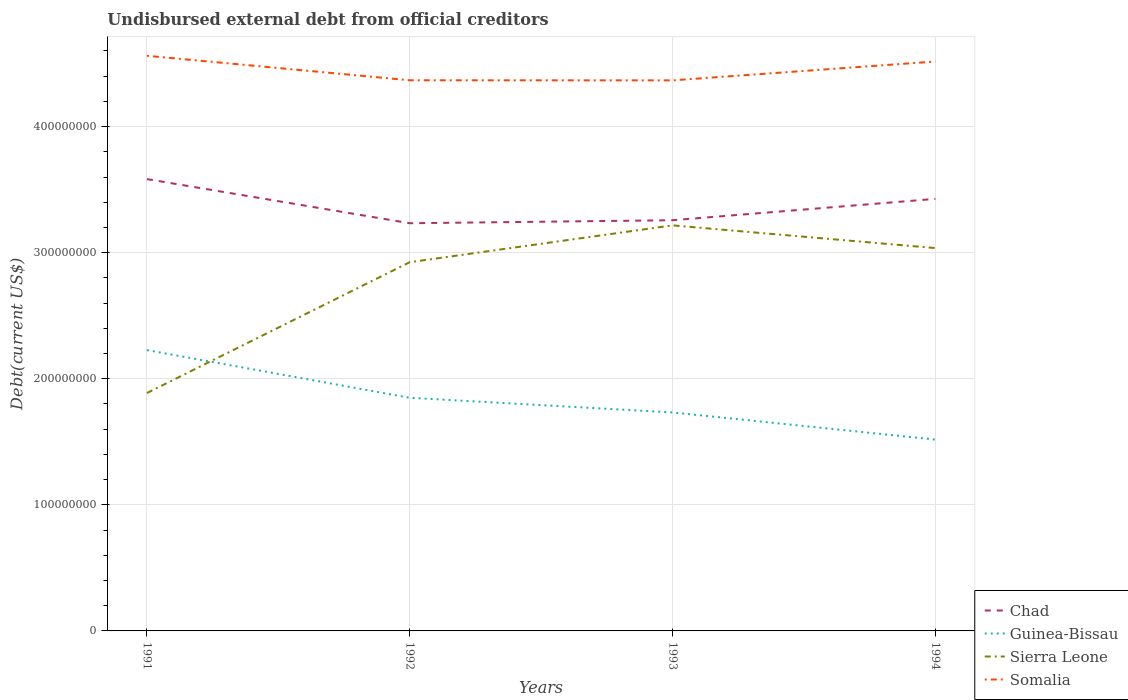How many different coloured lines are there?
Your answer should be very brief. 4. Across all years, what is the maximum total debt in Sierra Leone?
Give a very brief answer. 1.89e+08. In which year was the total debt in Chad maximum?
Your answer should be compact. 1992. What is the total total debt in Chad in the graph?
Ensure brevity in your answer.  3.26e+07. What is the difference between the highest and the second highest total debt in Chad?
Ensure brevity in your answer.  3.50e+07. What is the difference between the highest and the lowest total debt in Somalia?
Make the answer very short. 2. How many lines are there?
Offer a terse response. 4. How many years are there in the graph?
Offer a very short reply. 4. Are the values on the major ticks of Y-axis written in scientific E-notation?
Give a very brief answer. No. How many legend labels are there?
Make the answer very short. 4. What is the title of the graph?
Your answer should be very brief. Undisbursed external debt from official creditors. Does "Belarus" appear as one of the legend labels in the graph?
Your response must be concise. No. What is the label or title of the X-axis?
Give a very brief answer. Years. What is the label or title of the Y-axis?
Keep it short and to the point. Debt(current US$). What is the Debt(current US$) in Chad in 1991?
Ensure brevity in your answer.  3.58e+08. What is the Debt(current US$) in Guinea-Bissau in 1991?
Give a very brief answer. 2.23e+08. What is the Debt(current US$) in Sierra Leone in 1991?
Ensure brevity in your answer.  1.89e+08. What is the Debt(current US$) of Somalia in 1991?
Give a very brief answer. 4.56e+08. What is the Debt(current US$) in Chad in 1992?
Keep it short and to the point. 3.23e+08. What is the Debt(current US$) in Guinea-Bissau in 1992?
Your response must be concise. 1.85e+08. What is the Debt(current US$) in Sierra Leone in 1992?
Give a very brief answer. 2.92e+08. What is the Debt(current US$) in Somalia in 1992?
Your answer should be compact. 4.37e+08. What is the Debt(current US$) in Chad in 1993?
Your answer should be very brief. 3.26e+08. What is the Debt(current US$) in Guinea-Bissau in 1993?
Ensure brevity in your answer.  1.73e+08. What is the Debt(current US$) of Sierra Leone in 1993?
Give a very brief answer. 3.22e+08. What is the Debt(current US$) of Somalia in 1993?
Offer a terse response. 4.37e+08. What is the Debt(current US$) of Chad in 1994?
Keep it short and to the point. 3.43e+08. What is the Debt(current US$) in Guinea-Bissau in 1994?
Ensure brevity in your answer.  1.52e+08. What is the Debt(current US$) in Sierra Leone in 1994?
Offer a terse response. 3.04e+08. What is the Debt(current US$) of Somalia in 1994?
Offer a terse response. 4.52e+08. Across all years, what is the maximum Debt(current US$) in Chad?
Provide a succinct answer. 3.58e+08. Across all years, what is the maximum Debt(current US$) of Guinea-Bissau?
Give a very brief answer. 2.23e+08. Across all years, what is the maximum Debt(current US$) in Sierra Leone?
Make the answer very short. 3.22e+08. Across all years, what is the maximum Debt(current US$) in Somalia?
Keep it short and to the point. 4.56e+08. Across all years, what is the minimum Debt(current US$) of Chad?
Make the answer very short. 3.23e+08. Across all years, what is the minimum Debt(current US$) in Guinea-Bissau?
Offer a terse response. 1.52e+08. Across all years, what is the minimum Debt(current US$) in Sierra Leone?
Your response must be concise. 1.89e+08. Across all years, what is the minimum Debt(current US$) of Somalia?
Give a very brief answer. 4.37e+08. What is the total Debt(current US$) in Chad in the graph?
Ensure brevity in your answer.  1.35e+09. What is the total Debt(current US$) of Guinea-Bissau in the graph?
Offer a very short reply. 7.33e+08. What is the total Debt(current US$) of Sierra Leone in the graph?
Keep it short and to the point. 1.11e+09. What is the total Debt(current US$) in Somalia in the graph?
Offer a terse response. 1.78e+09. What is the difference between the Debt(current US$) in Chad in 1991 and that in 1992?
Provide a succinct answer. 3.50e+07. What is the difference between the Debt(current US$) of Guinea-Bissau in 1991 and that in 1992?
Keep it short and to the point. 3.78e+07. What is the difference between the Debt(current US$) of Sierra Leone in 1991 and that in 1992?
Your response must be concise. -1.04e+08. What is the difference between the Debt(current US$) of Somalia in 1991 and that in 1992?
Make the answer very short. 1.94e+07. What is the difference between the Debt(current US$) in Chad in 1991 and that in 1993?
Offer a terse response. 3.26e+07. What is the difference between the Debt(current US$) of Guinea-Bissau in 1991 and that in 1993?
Give a very brief answer. 4.94e+07. What is the difference between the Debt(current US$) of Sierra Leone in 1991 and that in 1993?
Your response must be concise. -1.33e+08. What is the difference between the Debt(current US$) in Somalia in 1991 and that in 1993?
Provide a short and direct response. 1.95e+07. What is the difference between the Debt(current US$) in Chad in 1991 and that in 1994?
Keep it short and to the point. 1.57e+07. What is the difference between the Debt(current US$) in Guinea-Bissau in 1991 and that in 1994?
Keep it short and to the point. 7.10e+07. What is the difference between the Debt(current US$) of Sierra Leone in 1991 and that in 1994?
Your answer should be compact. -1.15e+08. What is the difference between the Debt(current US$) in Somalia in 1991 and that in 1994?
Provide a short and direct response. 4.55e+06. What is the difference between the Debt(current US$) of Chad in 1992 and that in 1993?
Offer a very short reply. -2.39e+06. What is the difference between the Debt(current US$) of Guinea-Bissau in 1992 and that in 1993?
Give a very brief answer. 1.16e+07. What is the difference between the Debt(current US$) in Sierra Leone in 1992 and that in 1993?
Give a very brief answer. -2.92e+07. What is the difference between the Debt(current US$) in Somalia in 1992 and that in 1993?
Offer a very short reply. 6.70e+04. What is the difference between the Debt(current US$) of Chad in 1992 and that in 1994?
Offer a very short reply. -1.93e+07. What is the difference between the Debt(current US$) in Guinea-Bissau in 1992 and that in 1994?
Give a very brief answer. 3.32e+07. What is the difference between the Debt(current US$) of Sierra Leone in 1992 and that in 1994?
Provide a short and direct response. -1.12e+07. What is the difference between the Debt(current US$) of Somalia in 1992 and that in 1994?
Your answer should be very brief. -1.49e+07. What is the difference between the Debt(current US$) of Chad in 1993 and that in 1994?
Give a very brief answer. -1.69e+07. What is the difference between the Debt(current US$) in Guinea-Bissau in 1993 and that in 1994?
Your answer should be compact. 2.16e+07. What is the difference between the Debt(current US$) in Sierra Leone in 1993 and that in 1994?
Your answer should be very brief. 1.80e+07. What is the difference between the Debt(current US$) in Somalia in 1993 and that in 1994?
Keep it short and to the point. -1.50e+07. What is the difference between the Debt(current US$) of Chad in 1991 and the Debt(current US$) of Guinea-Bissau in 1992?
Make the answer very short. 1.73e+08. What is the difference between the Debt(current US$) in Chad in 1991 and the Debt(current US$) in Sierra Leone in 1992?
Your response must be concise. 6.59e+07. What is the difference between the Debt(current US$) of Chad in 1991 and the Debt(current US$) of Somalia in 1992?
Your answer should be very brief. -7.84e+07. What is the difference between the Debt(current US$) in Guinea-Bissau in 1991 and the Debt(current US$) in Sierra Leone in 1992?
Your response must be concise. -6.97e+07. What is the difference between the Debt(current US$) in Guinea-Bissau in 1991 and the Debt(current US$) in Somalia in 1992?
Make the answer very short. -2.14e+08. What is the difference between the Debt(current US$) in Sierra Leone in 1991 and the Debt(current US$) in Somalia in 1992?
Your answer should be compact. -2.48e+08. What is the difference between the Debt(current US$) in Chad in 1991 and the Debt(current US$) in Guinea-Bissau in 1993?
Make the answer very short. 1.85e+08. What is the difference between the Debt(current US$) in Chad in 1991 and the Debt(current US$) in Sierra Leone in 1993?
Your answer should be compact. 3.67e+07. What is the difference between the Debt(current US$) of Chad in 1991 and the Debt(current US$) of Somalia in 1993?
Your answer should be very brief. -7.83e+07. What is the difference between the Debt(current US$) of Guinea-Bissau in 1991 and the Debt(current US$) of Sierra Leone in 1993?
Provide a succinct answer. -9.89e+07. What is the difference between the Debt(current US$) in Guinea-Bissau in 1991 and the Debt(current US$) in Somalia in 1993?
Your response must be concise. -2.14e+08. What is the difference between the Debt(current US$) of Sierra Leone in 1991 and the Debt(current US$) of Somalia in 1993?
Your answer should be very brief. -2.48e+08. What is the difference between the Debt(current US$) in Chad in 1991 and the Debt(current US$) in Guinea-Bissau in 1994?
Offer a terse response. 2.07e+08. What is the difference between the Debt(current US$) of Chad in 1991 and the Debt(current US$) of Sierra Leone in 1994?
Give a very brief answer. 5.47e+07. What is the difference between the Debt(current US$) in Chad in 1991 and the Debt(current US$) in Somalia in 1994?
Offer a terse response. -9.33e+07. What is the difference between the Debt(current US$) in Guinea-Bissau in 1991 and the Debt(current US$) in Sierra Leone in 1994?
Make the answer very short. -8.09e+07. What is the difference between the Debt(current US$) in Guinea-Bissau in 1991 and the Debt(current US$) in Somalia in 1994?
Ensure brevity in your answer.  -2.29e+08. What is the difference between the Debt(current US$) in Sierra Leone in 1991 and the Debt(current US$) in Somalia in 1994?
Offer a very short reply. -2.63e+08. What is the difference between the Debt(current US$) in Chad in 1992 and the Debt(current US$) in Guinea-Bissau in 1993?
Ensure brevity in your answer.  1.50e+08. What is the difference between the Debt(current US$) of Chad in 1992 and the Debt(current US$) of Sierra Leone in 1993?
Ensure brevity in your answer.  1.68e+06. What is the difference between the Debt(current US$) in Chad in 1992 and the Debt(current US$) in Somalia in 1993?
Make the answer very short. -1.13e+08. What is the difference between the Debt(current US$) in Guinea-Bissau in 1992 and the Debt(current US$) in Sierra Leone in 1993?
Keep it short and to the point. -1.37e+08. What is the difference between the Debt(current US$) in Guinea-Bissau in 1992 and the Debt(current US$) in Somalia in 1993?
Give a very brief answer. -2.52e+08. What is the difference between the Debt(current US$) in Sierra Leone in 1992 and the Debt(current US$) in Somalia in 1993?
Ensure brevity in your answer.  -1.44e+08. What is the difference between the Debt(current US$) of Chad in 1992 and the Debt(current US$) of Guinea-Bissau in 1994?
Give a very brief answer. 1.72e+08. What is the difference between the Debt(current US$) in Chad in 1992 and the Debt(current US$) in Sierra Leone in 1994?
Keep it short and to the point. 1.97e+07. What is the difference between the Debt(current US$) of Chad in 1992 and the Debt(current US$) of Somalia in 1994?
Provide a succinct answer. -1.28e+08. What is the difference between the Debt(current US$) of Guinea-Bissau in 1992 and the Debt(current US$) of Sierra Leone in 1994?
Make the answer very short. -1.19e+08. What is the difference between the Debt(current US$) of Guinea-Bissau in 1992 and the Debt(current US$) of Somalia in 1994?
Offer a terse response. -2.67e+08. What is the difference between the Debt(current US$) of Sierra Leone in 1992 and the Debt(current US$) of Somalia in 1994?
Your answer should be very brief. -1.59e+08. What is the difference between the Debt(current US$) in Chad in 1993 and the Debt(current US$) in Guinea-Bissau in 1994?
Your answer should be compact. 1.74e+08. What is the difference between the Debt(current US$) of Chad in 1993 and the Debt(current US$) of Sierra Leone in 1994?
Keep it short and to the point. 2.21e+07. What is the difference between the Debt(current US$) in Chad in 1993 and the Debt(current US$) in Somalia in 1994?
Keep it short and to the point. -1.26e+08. What is the difference between the Debt(current US$) in Guinea-Bissau in 1993 and the Debt(current US$) in Sierra Leone in 1994?
Keep it short and to the point. -1.30e+08. What is the difference between the Debt(current US$) in Guinea-Bissau in 1993 and the Debt(current US$) in Somalia in 1994?
Your response must be concise. -2.78e+08. What is the difference between the Debt(current US$) of Sierra Leone in 1993 and the Debt(current US$) of Somalia in 1994?
Offer a very short reply. -1.30e+08. What is the average Debt(current US$) in Chad per year?
Give a very brief answer. 3.38e+08. What is the average Debt(current US$) of Guinea-Bissau per year?
Give a very brief answer. 1.83e+08. What is the average Debt(current US$) in Sierra Leone per year?
Offer a very short reply. 2.77e+08. What is the average Debt(current US$) of Somalia per year?
Your response must be concise. 4.45e+08. In the year 1991, what is the difference between the Debt(current US$) of Chad and Debt(current US$) of Guinea-Bissau?
Your answer should be very brief. 1.36e+08. In the year 1991, what is the difference between the Debt(current US$) of Chad and Debt(current US$) of Sierra Leone?
Your answer should be very brief. 1.70e+08. In the year 1991, what is the difference between the Debt(current US$) of Chad and Debt(current US$) of Somalia?
Keep it short and to the point. -9.78e+07. In the year 1991, what is the difference between the Debt(current US$) of Guinea-Bissau and Debt(current US$) of Sierra Leone?
Your response must be concise. 3.41e+07. In the year 1991, what is the difference between the Debt(current US$) in Guinea-Bissau and Debt(current US$) in Somalia?
Offer a terse response. -2.33e+08. In the year 1991, what is the difference between the Debt(current US$) of Sierra Leone and Debt(current US$) of Somalia?
Provide a succinct answer. -2.68e+08. In the year 1992, what is the difference between the Debt(current US$) of Chad and Debt(current US$) of Guinea-Bissau?
Your answer should be very brief. 1.38e+08. In the year 1992, what is the difference between the Debt(current US$) in Chad and Debt(current US$) in Sierra Leone?
Keep it short and to the point. 3.09e+07. In the year 1992, what is the difference between the Debt(current US$) in Chad and Debt(current US$) in Somalia?
Keep it short and to the point. -1.13e+08. In the year 1992, what is the difference between the Debt(current US$) of Guinea-Bissau and Debt(current US$) of Sierra Leone?
Offer a terse response. -1.08e+08. In the year 1992, what is the difference between the Debt(current US$) in Guinea-Bissau and Debt(current US$) in Somalia?
Ensure brevity in your answer.  -2.52e+08. In the year 1992, what is the difference between the Debt(current US$) of Sierra Leone and Debt(current US$) of Somalia?
Provide a succinct answer. -1.44e+08. In the year 1993, what is the difference between the Debt(current US$) in Chad and Debt(current US$) in Guinea-Bissau?
Offer a terse response. 1.52e+08. In the year 1993, what is the difference between the Debt(current US$) of Chad and Debt(current US$) of Sierra Leone?
Provide a succinct answer. 4.07e+06. In the year 1993, what is the difference between the Debt(current US$) in Chad and Debt(current US$) in Somalia?
Keep it short and to the point. -1.11e+08. In the year 1993, what is the difference between the Debt(current US$) of Guinea-Bissau and Debt(current US$) of Sierra Leone?
Offer a terse response. -1.48e+08. In the year 1993, what is the difference between the Debt(current US$) in Guinea-Bissau and Debt(current US$) in Somalia?
Ensure brevity in your answer.  -2.63e+08. In the year 1993, what is the difference between the Debt(current US$) of Sierra Leone and Debt(current US$) of Somalia?
Offer a terse response. -1.15e+08. In the year 1994, what is the difference between the Debt(current US$) in Chad and Debt(current US$) in Guinea-Bissau?
Keep it short and to the point. 1.91e+08. In the year 1994, what is the difference between the Debt(current US$) in Chad and Debt(current US$) in Sierra Leone?
Provide a succinct answer. 3.90e+07. In the year 1994, what is the difference between the Debt(current US$) in Chad and Debt(current US$) in Somalia?
Your answer should be very brief. -1.09e+08. In the year 1994, what is the difference between the Debt(current US$) in Guinea-Bissau and Debt(current US$) in Sierra Leone?
Offer a very short reply. -1.52e+08. In the year 1994, what is the difference between the Debt(current US$) in Guinea-Bissau and Debt(current US$) in Somalia?
Offer a terse response. -3.00e+08. In the year 1994, what is the difference between the Debt(current US$) in Sierra Leone and Debt(current US$) in Somalia?
Offer a very short reply. -1.48e+08. What is the ratio of the Debt(current US$) in Chad in 1991 to that in 1992?
Your answer should be compact. 1.11. What is the ratio of the Debt(current US$) of Guinea-Bissau in 1991 to that in 1992?
Offer a terse response. 1.2. What is the ratio of the Debt(current US$) of Sierra Leone in 1991 to that in 1992?
Your response must be concise. 0.65. What is the ratio of the Debt(current US$) of Somalia in 1991 to that in 1992?
Provide a short and direct response. 1.04. What is the ratio of the Debt(current US$) in Chad in 1991 to that in 1993?
Ensure brevity in your answer.  1.1. What is the ratio of the Debt(current US$) of Guinea-Bissau in 1991 to that in 1993?
Your response must be concise. 1.29. What is the ratio of the Debt(current US$) in Sierra Leone in 1991 to that in 1993?
Provide a short and direct response. 0.59. What is the ratio of the Debt(current US$) of Somalia in 1991 to that in 1993?
Make the answer very short. 1.04. What is the ratio of the Debt(current US$) of Chad in 1991 to that in 1994?
Your answer should be compact. 1.05. What is the ratio of the Debt(current US$) in Guinea-Bissau in 1991 to that in 1994?
Provide a short and direct response. 1.47. What is the ratio of the Debt(current US$) of Sierra Leone in 1991 to that in 1994?
Keep it short and to the point. 0.62. What is the ratio of the Debt(current US$) of Somalia in 1991 to that in 1994?
Ensure brevity in your answer.  1.01. What is the ratio of the Debt(current US$) in Chad in 1992 to that in 1993?
Give a very brief answer. 0.99. What is the ratio of the Debt(current US$) of Guinea-Bissau in 1992 to that in 1993?
Keep it short and to the point. 1.07. What is the ratio of the Debt(current US$) in Sierra Leone in 1992 to that in 1993?
Offer a terse response. 0.91. What is the ratio of the Debt(current US$) in Chad in 1992 to that in 1994?
Make the answer very short. 0.94. What is the ratio of the Debt(current US$) in Guinea-Bissau in 1992 to that in 1994?
Offer a terse response. 1.22. What is the ratio of the Debt(current US$) in Sierra Leone in 1992 to that in 1994?
Offer a terse response. 0.96. What is the ratio of the Debt(current US$) of Somalia in 1992 to that in 1994?
Give a very brief answer. 0.97. What is the ratio of the Debt(current US$) in Chad in 1993 to that in 1994?
Provide a succinct answer. 0.95. What is the ratio of the Debt(current US$) of Guinea-Bissau in 1993 to that in 1994?
Your response must be concise. 1.14. What is the ratio of the Debt(current US$) in Sierra Leone in 1993 to that in 1994?
Give a very brief answer. 1.06. What is the ratio of the Debt(current US$) of Somalia in 1993 to that in 1994?
Your answer should be very brief. 0.97. What is the difference between the highest and the second highest Debt(current US$) of Chad?
Provide a short and direct response. 1.57e+07. What is the difference between the highest and the second highest Debt(current US$) of Guinea-Bissau?
Keep it short and to the point. 3.78e+07. What is the difference between the highest and the second highest Debt(current US$) of Sierra Leone?
Keep it short and to the point. 1.80e+07. What is the difference between the highest and the second highest Debt(current US$) in Somalia?
Your response must be concise. 4.55e+06. What is the difference between the highest and the lowest Debt(current US$) in Chad?
Your answer should be very brief. 3.50e+07. What is the difference between the highest and the lowest Debt(current US$) of Guinea-Bissau?
Your response must be concise. 7.10e+07. What is the difference between the highest and the lowest Debt(current US$) in Sierra Leone?
Provide a succinct answer. 1.33e+08. What is the difference between the highest and the lowest Debt(current US$) of Somalia?
Your response must be concise. 1.95e+07. 